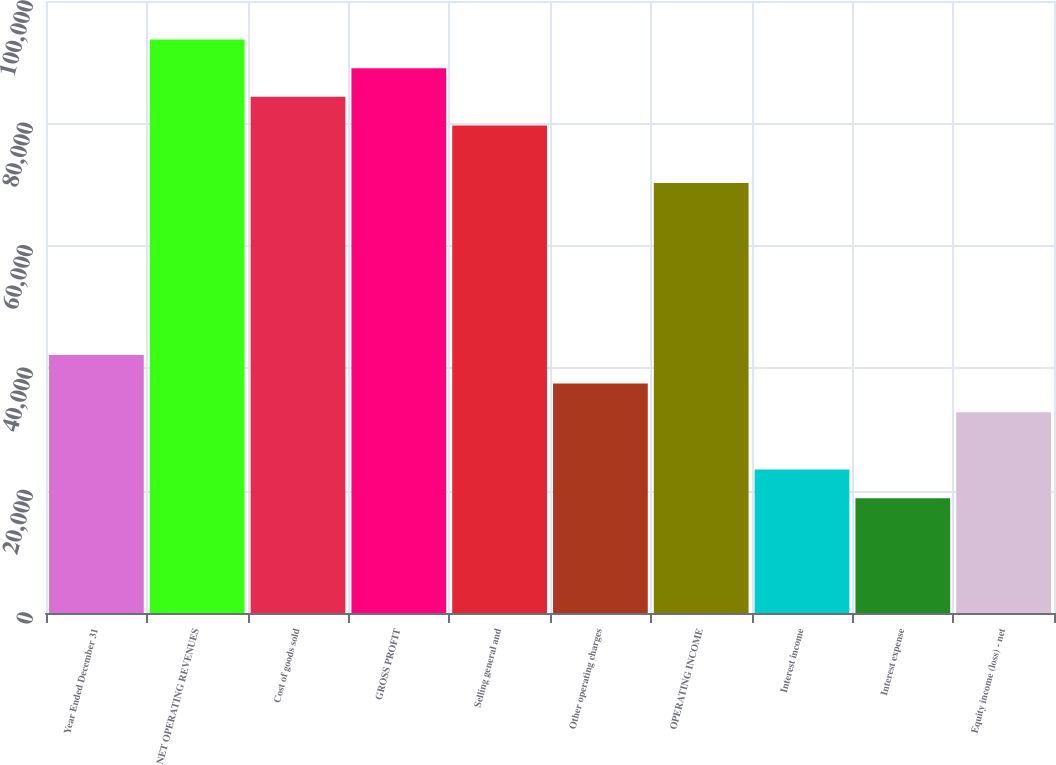Convert chart. <chart><loc_0><loc_0><loc_500><loc_500><bar_chart><fcel>Year Ended December 31<fcel>NET OPERATING REVENUES<fcel>Cost of goods sold<fcel>GROSS PROFIT<fcel>Selling general and<fcel>Other operating charges<fcel>OPERATING INCOME<fcel>Interest income<fcel>Interest expense<fcel>Equity income (loss) - net<nl><fcel>42168.8<fcel>93706.1<fcel>84335.7<fcel>89020.9<fcel>79650.5<fcel>37483.6<fcel>70280.1<fcel>23428<fcel>18742.7<fcel>32798.4<nl></chart> 